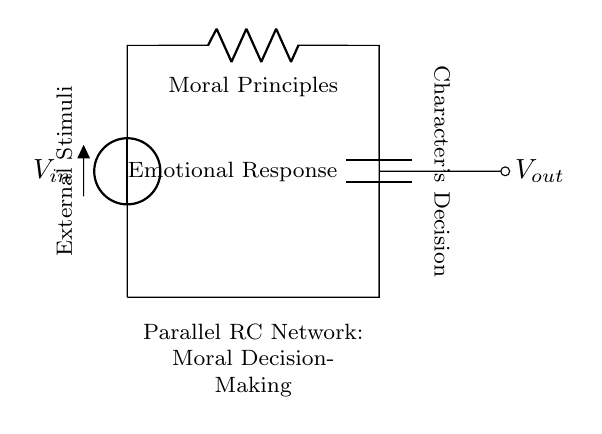What type of components are in this circuit? The circuit consists of a resistor and a capacitor. The resistor is labeled as "Moral Principles" and the capacitor is labeled as "Emotional Response."
Answer: Resistor and Capacitor What does the resistor represent in the circuit? The resistor is labeled with "Moral Principles," indicating it represents the principles that constrain the character's decisions.
Answer: Moral Principles What does the capacitor's label signify? The capacitor is labeled "Emotional Response," which represents how emotions can accumulate and influence a character's choices over time.
Answer: Emotional Response Is the capacitor in this circuit charging or discharging? The circuit diagram does not explicitly indicate a charging or discharging state; it illustrates a steady-state condition where the character's decision is influenced by both moral principles and emotional responses.
Answer: Steady-state What influences the character's decision in this circuit? The character's decision is influenced by both external stimuli, represented by the voltage input, and the parallel combination of the resistor and capacitor, which relates to moral and emotional inputs.
Answer: External stimuli How does increasing the resistor value affect the circuit's behavior? Increasing the resistor value would slow down the response of the capacitor, leading to a longer delay before the emotional response affects the character's decision-making process.
Answer: Slows response What is the role of voltage input in the circuit? The voltage input, labeled "Vin," represents external stimuli that drive the decision-making process, serving as the energy input for the character's moral and emotional evaluation.
Answer: Energy input 